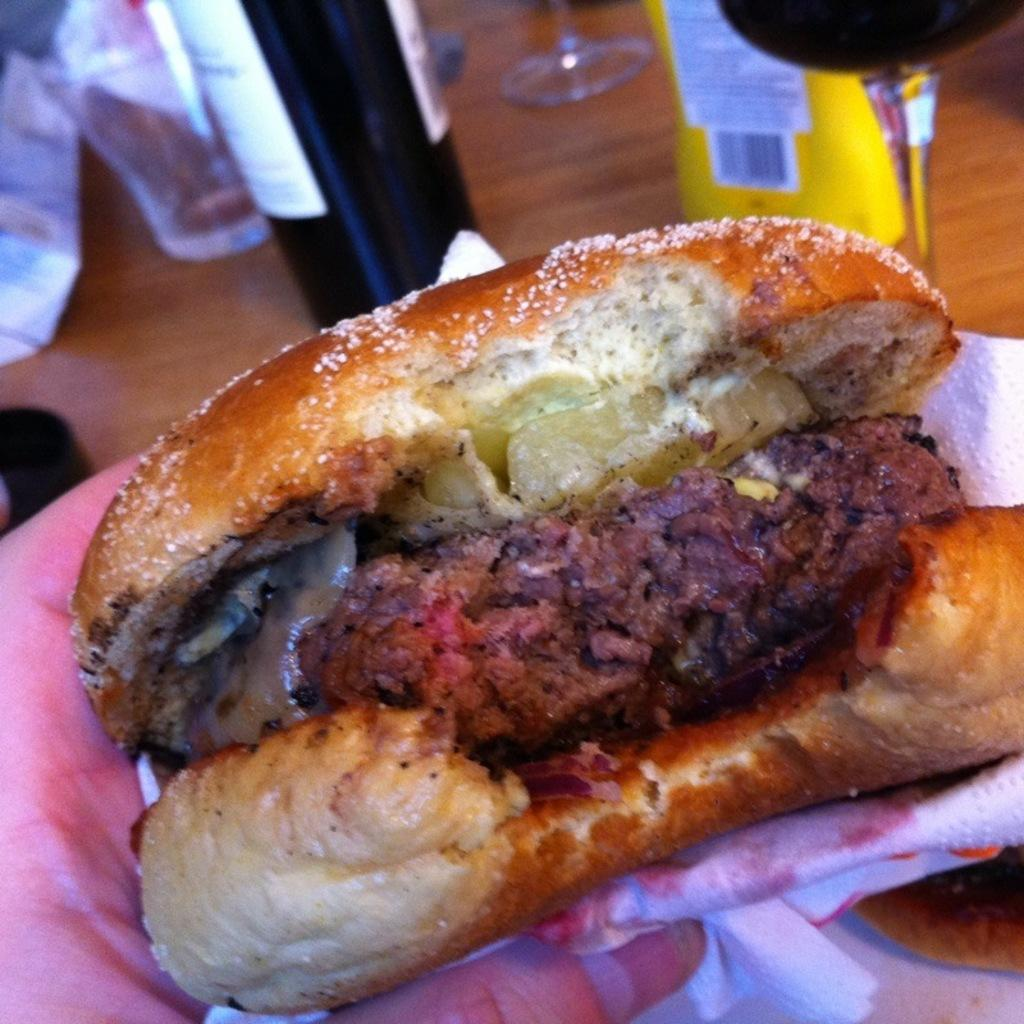What is the hand in the image holding? The hand in the image is holding food. Who does the hand belong to? The hand belongs to a person. What is the setting of the image? There is a table in the image. What else can be seen on the table? There is a bottle, glasses, and a food packet on the table. Can you see a river flowing in the background of the image? There is no river visible in the image; it features a hand holding food, a table, and various items on the table. 